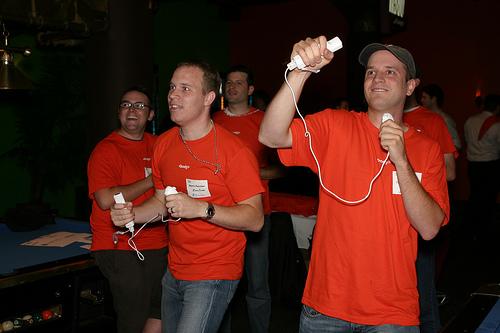Are they having fun?
Answer briefly. Yes. What game system are they playing?
Write a very short answer. Wii. What color are their shirts?
Write a very short answer. Orange. 